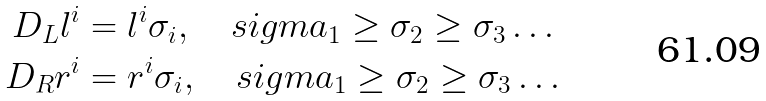<formula> <loc_0><loc_0><loc_500><loc_500>D _ { L } l ^ { i } & = l ^ { i } \sigma _ { i } , \quad s i g m a _ { 1 } \geq \sigma _ { 2 } \geq \sigma _ { 3 } \dots \\ D _ { R } r ^ { i } & = r ^ { i } \sigma _ { i } , \quad s i g m a _ { 1 } \geq \sigma _ { 2 } \geq \sigma _ { 3 } \dots</formula> 